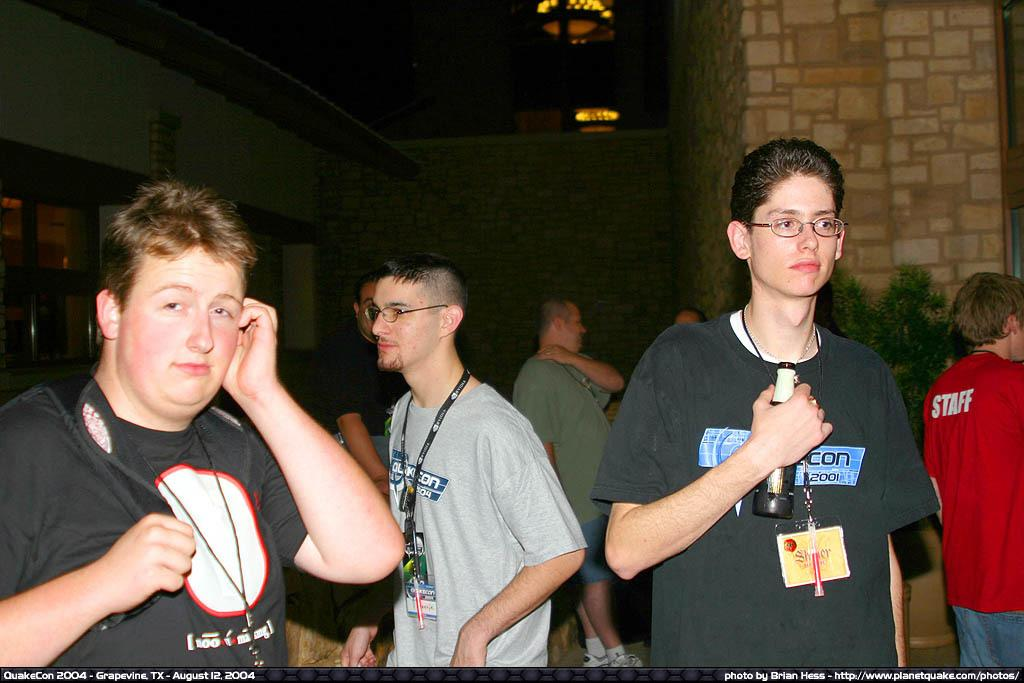What is happening in the image? There is a group of people standing in the image. Can you describe the actions of one of the individuals? There is a person holding a bottle in the image. What can be seen in the background of the image? There is a plant and lights in the background of the image. Are there any visible imperfections or marks on the image? Yes, there are watermarks on the image. What type of curtain can be seen hanging from the ceiling in the image? There is no curtain present in the image. How many hens are visible in the image? There are no hens present in the image. 